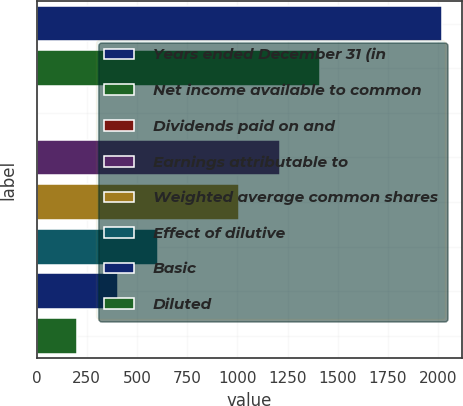Convert chart to OTSL. <chart><loc_0><loc_0><loc_500><loc_500><bar_chart><fcel>Years ended December 31 (in<fcel>Net income available to common<fcel>Dividends paid on and<fcel>Earnings attributable to<fcel>Weighted average common shares<fcel>Effect of dilutive<fcel>Basic<fcel>Diluted<nl><fcel>2018<fcel>1412.66<fcel>0.2<fcel>1210.88<fcel>1009.1<fcel>605.54<fcel>403.76<fcel>201.98<nl></chart> 